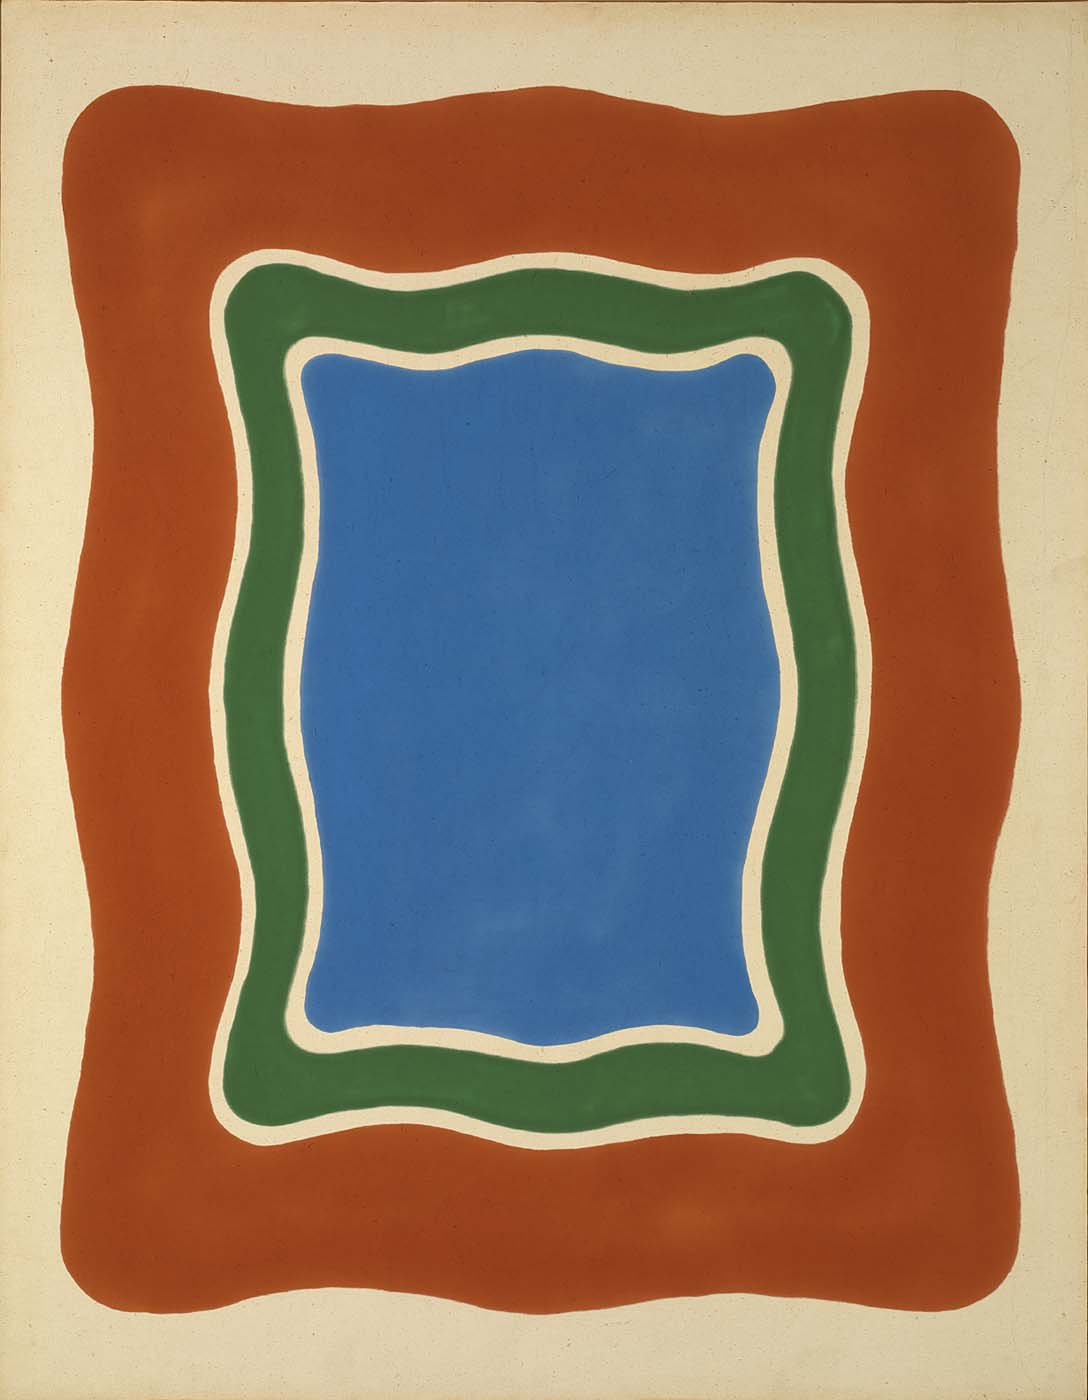If this image were a city, what kind of city would it be? Imagine a city where the heart is an expansive blue park, a sanctuary of calm amidst the urban bustle. The green belt surrounds it like a network of eco-friendly transport systems and lush greenways, connecting neighborhoods. The outer red zone is the vibrant downtown, bustling with markets, galleries, and colorful street art. This city thrives on balance and interaction, where structured serenity coexists harmoniously with dynamic creativity. Its streets flow organically, encouraging exploration and discovery at every turn. 